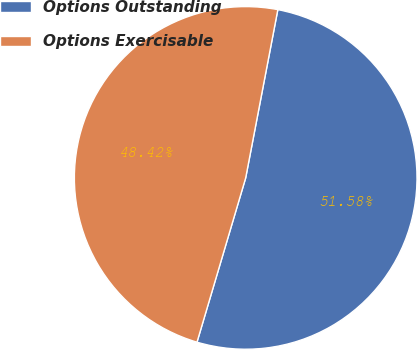Convert chart. <chart><loc_0><loc_0><loc_500><loc_500><pie_chart><fcel>Options Outstanding<fcel>Options Exercisable<nl><fcel>51.58%<fcel>48.42%<nl></chart> 